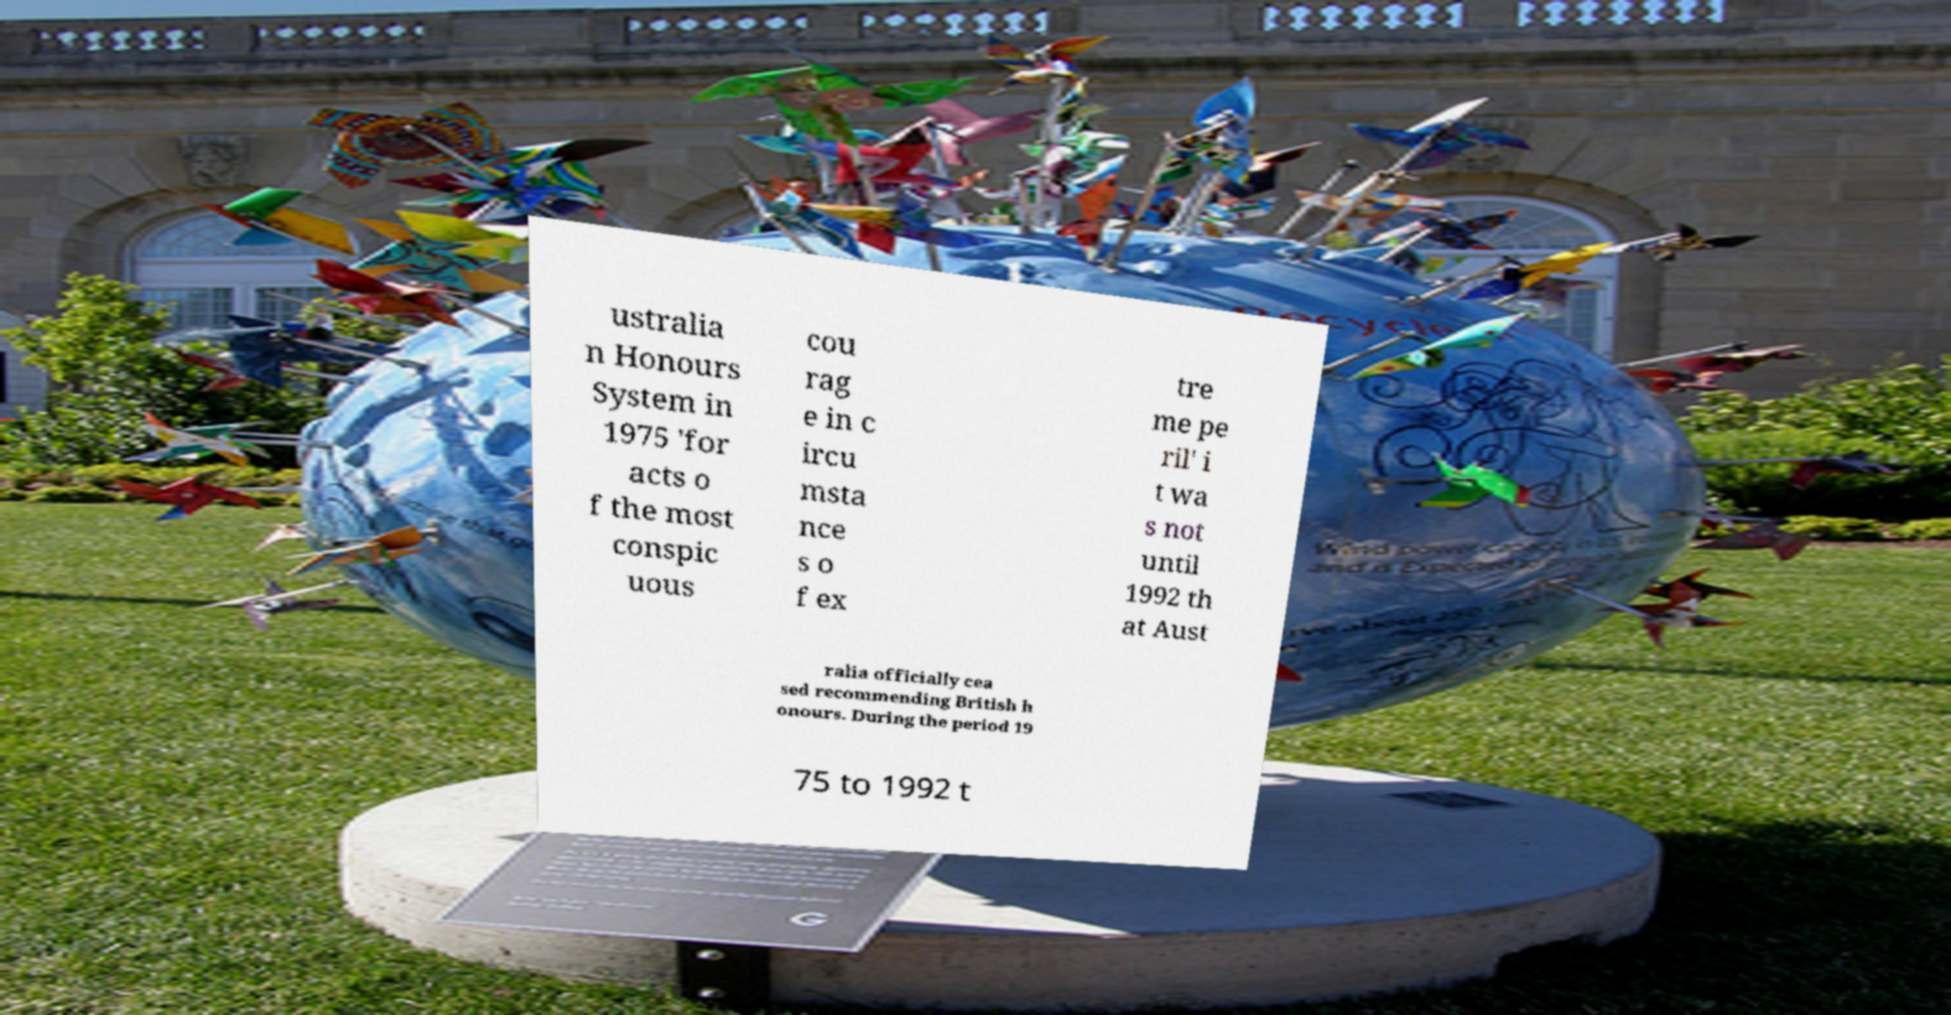Could you assist in decoding the text presented in this image and type it out clearly? ustralia n Honours System in 1975 'for acts o f the most conspic uous cou rag e in c ircu msta nce s o f ex tre me pe ril' i t wa s not until 1992 th at Aust ralia officially cea sed recommending British h onours. During the period 19 75 to 1992 t 